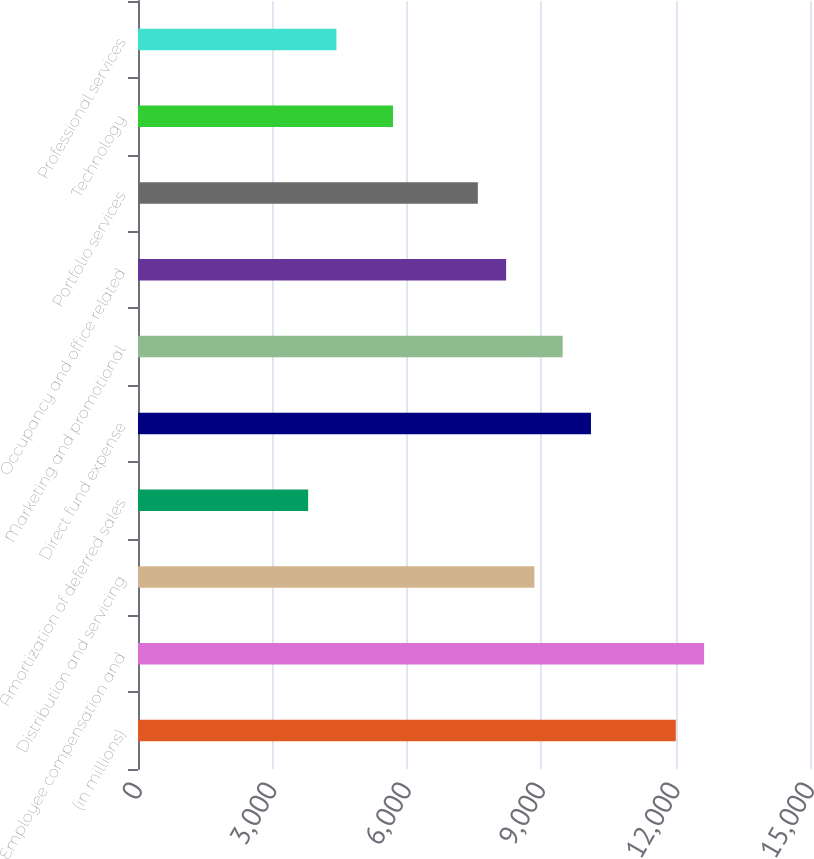Convert chart. <chart><loc_0><loc_0><loc_500><loc_500><bar_chart><fcel>(in millions)<fcel>Employee compensation and<fcel>Distribution and servicing<fcel>Amortization of deferred sales<fcel>Direct fund expense<fcel>Marketing and promotional<fcel>Occupancy and office related<fcel>Portfolio services<fcel>Technology<fcel>Professional services<nl><fcel>12004.7<fcel>12636<fcel>8848.2<fcel>3797.8<fcel>10110.8<fcel>9479.5<fcel>8216.9<fcel>7585.6<fcel>5691.7<fcel>4429.1<nl></chart> 